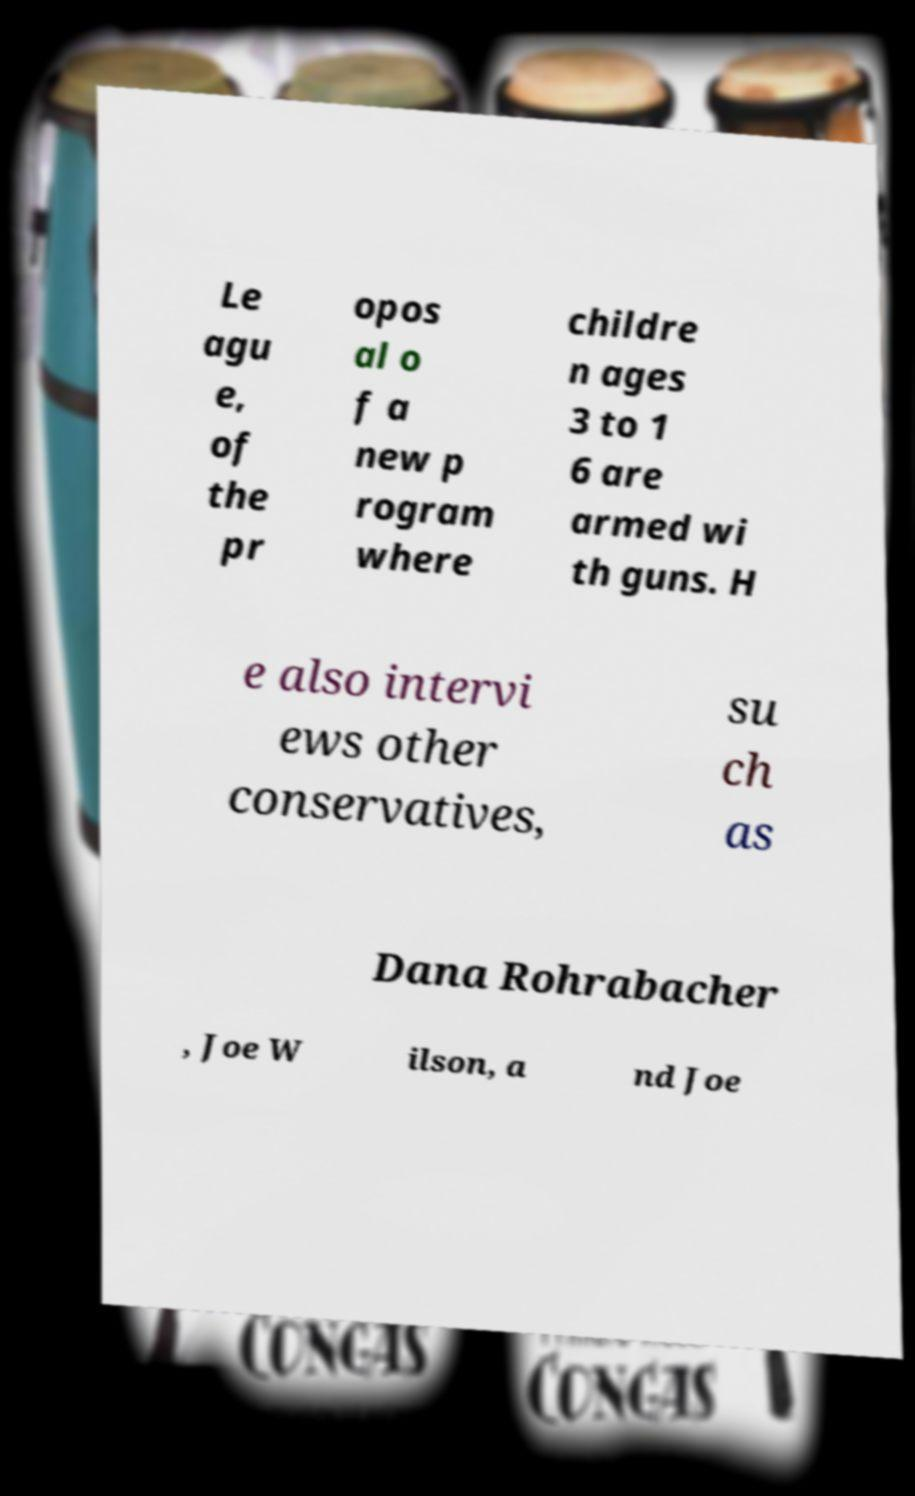Can you read and provide the text displayed in the image?This photo seems to have some interesting text. Can you extract and type it out for me? Le agu e, of the pr opos al o f a new p rogram where childre n ages 3 to 1 6 are armed wi th guns. H e also intervi ews other conservatives, su ch as Dana Rohrabacher , Joe W ilson, a nd Joe 